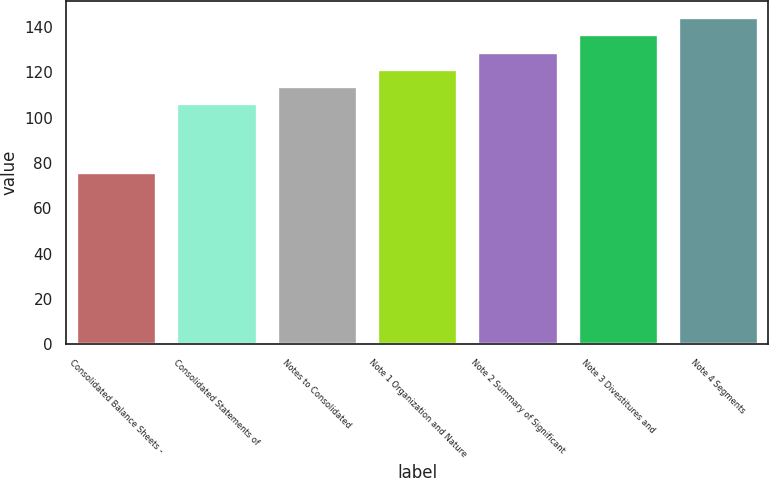<chart> <loc_0><loc_0><loc_500><loc_500><bar_chart><fcel>Consolidated Balance Sheets -<fcel>Consolidated Statements of<fcel>Notes to Consolidated<fcel>Note 1 Organization and Nature<fcel>Note 2 Summary of Significant<fcel>Note 3 Divestitures and<fcel>Note 4 Segments<nl><fcel>76<fcel>106.4<fcel>114<fcel>121.6<fcel>129.2<fcel>136.8<fcel>144.4<nl></chart> 